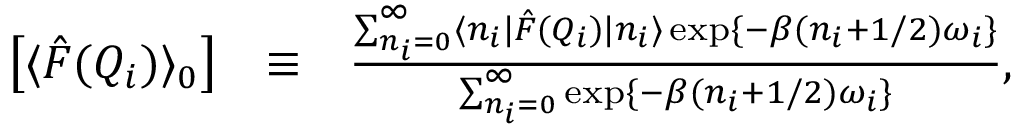<formula> <loc_0><loc_0><loc_500><loc_500>\begin{array} { r l r } { \left [ \langle \hat { F } ( Q _ { i } ) \rangle _ { 0 } \right ] } & { \equiv } & { \frac { \sum _ { n _ { i } = 0 } ^ { \infty } \langle n _ { i } | \hat { F } ( Q _ { i } ) | n _ { i } \rangle \exp \{ - \beta ( n _ { i } + 1 / 2 ) \omega _ { i } \} } { \sum _ { n _ { i } = 0 } ^ { \infty } \exp \{ - \beta ( n _ { i } + 1 / 2 ) \omega _ { i } \} } , } \end{array}</formula> 